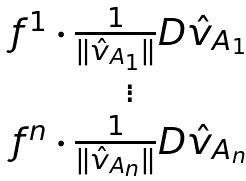<formula> <loc_0><loc_0><loc_500><loc_500>\begin{matrix} f ^ { 1 } \cdot \frac { 1 } { \| \hat { v } _ { A _ { 1 } } \| } D \hat { v } _ { A _ { 1 } } \\ \vdots \\ f ^ { n } \cdot \frac { 1 } { \| \hat { v } _ { A _ { n } } \| } D \hat { v } _ { A _ { n } } \end{matrix}</formula> 